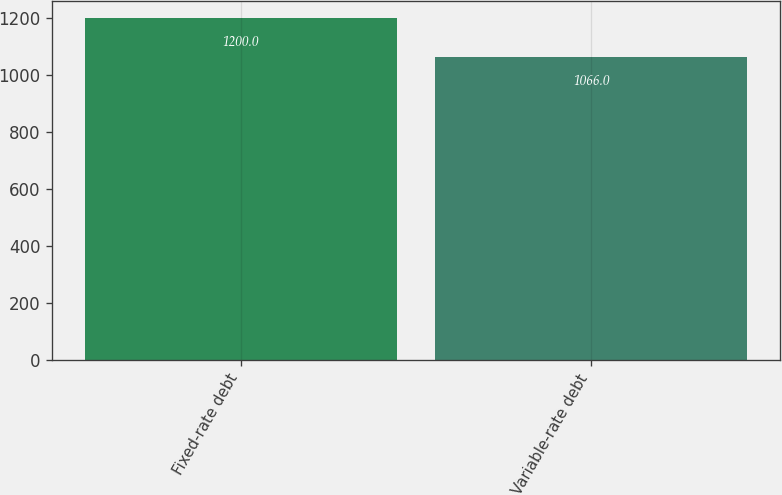Convert chart to OTSL. <chart><loc_0><loc_0><loc_500><loc_500><bar_chart><fcel>Fixed-rate debt<fcel>Variable-rate debt<nl><fcel>1200<fcel>1066<nl></chart> 